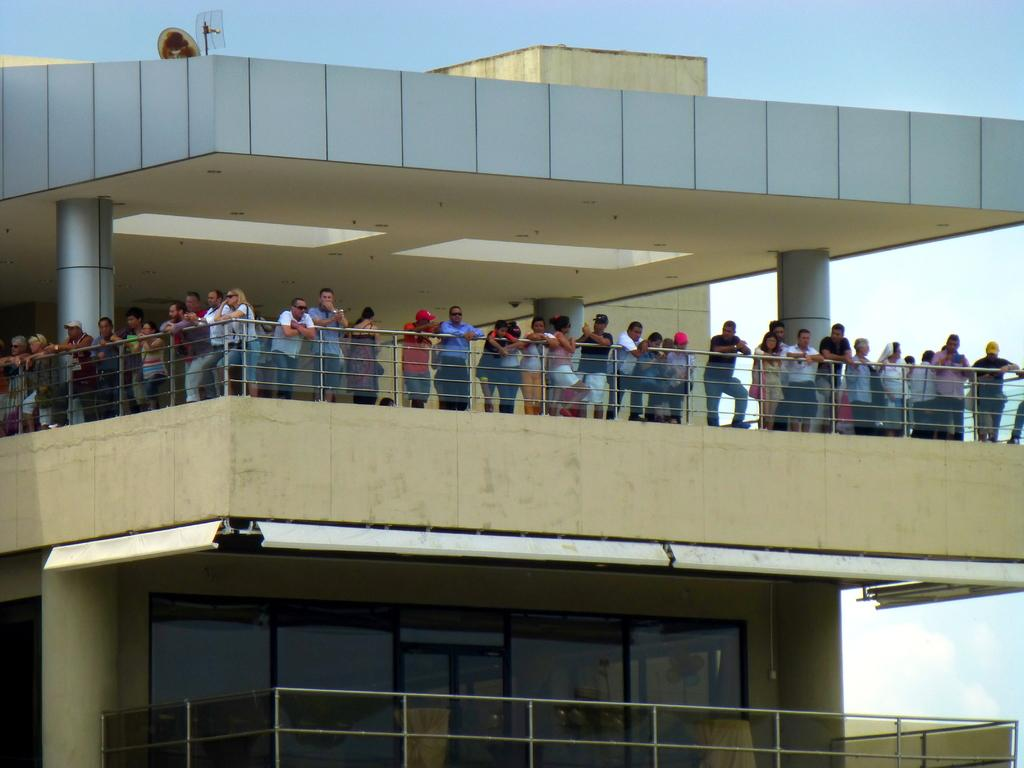What are the people in the image doing? The people in the image are standing at the balcony. What are the people looking at or towards? The people are looking around somewhere. What can be seen in the background of the image? The background of the image is the sky. Can you tell me how many goats are visible on the balcony in the image? There are no goats visible on the balcony in the image. What type of skin is visible on the people in the image? The provided facts do not mention the skin of the people, so we cannot determine the type of skin visible in the image. 